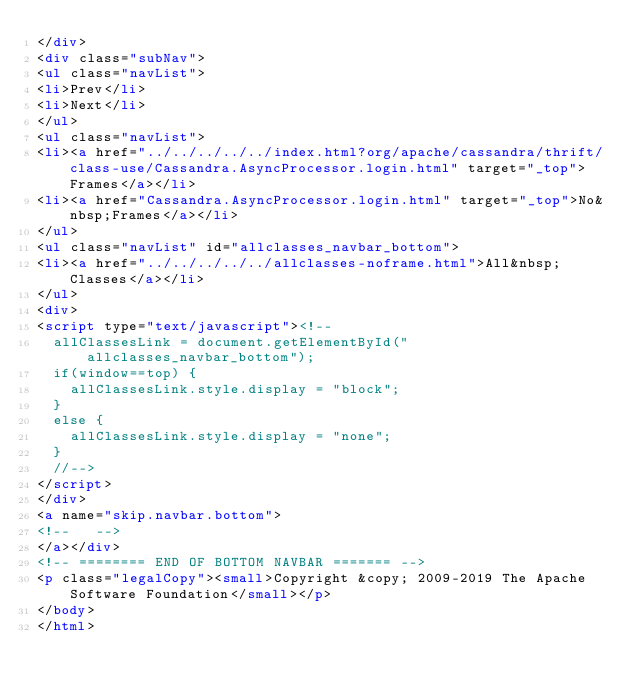<code> <loc_0><loc_0><loc_500><loc_500><_HTML_></div>
<div class="subNav">
<ul class="navList">
<li>Prev</li>
<li>Next</li>
</ul>
<ul class="navList">
<li><a href="../../../../../index.html?org/apache/cassandra/thrift/class-use/Cassandra.AsyncProcessor.login.html" target="_top">Frames</a></li>
<li><a href="Cassandra.AsyncProcessor.login.html" target="_top">No&nbsp;Frames</a></li>
</ul>
<ul class="navList" id="allclasses_navbar_bottom">
<li><a href="../../../../../allclasses-noframe.html">All&nbsp;Classes</a></li>
</ul>
<div>
<script type="text/javascript"><!--
  allClassesLink = document.getElementById("allclasses_navbar_bottom");
  if(window==top) {
    allClassesLink.style.display = "block";
  }
  else {
    allClassesLink.style.display = "none";
  }
  //-->
</script>
</div>
<a name="skip.navbar.bottom">
<!--   -->
</a></div>
<!-- ======== END OF BOTTOM NAVBAR ======= -->
<p class="legalCopy"><small>Copyright &copy; 2009-2019 The Apache Software Foundation</small></p>
</body>
</html>
</code> 